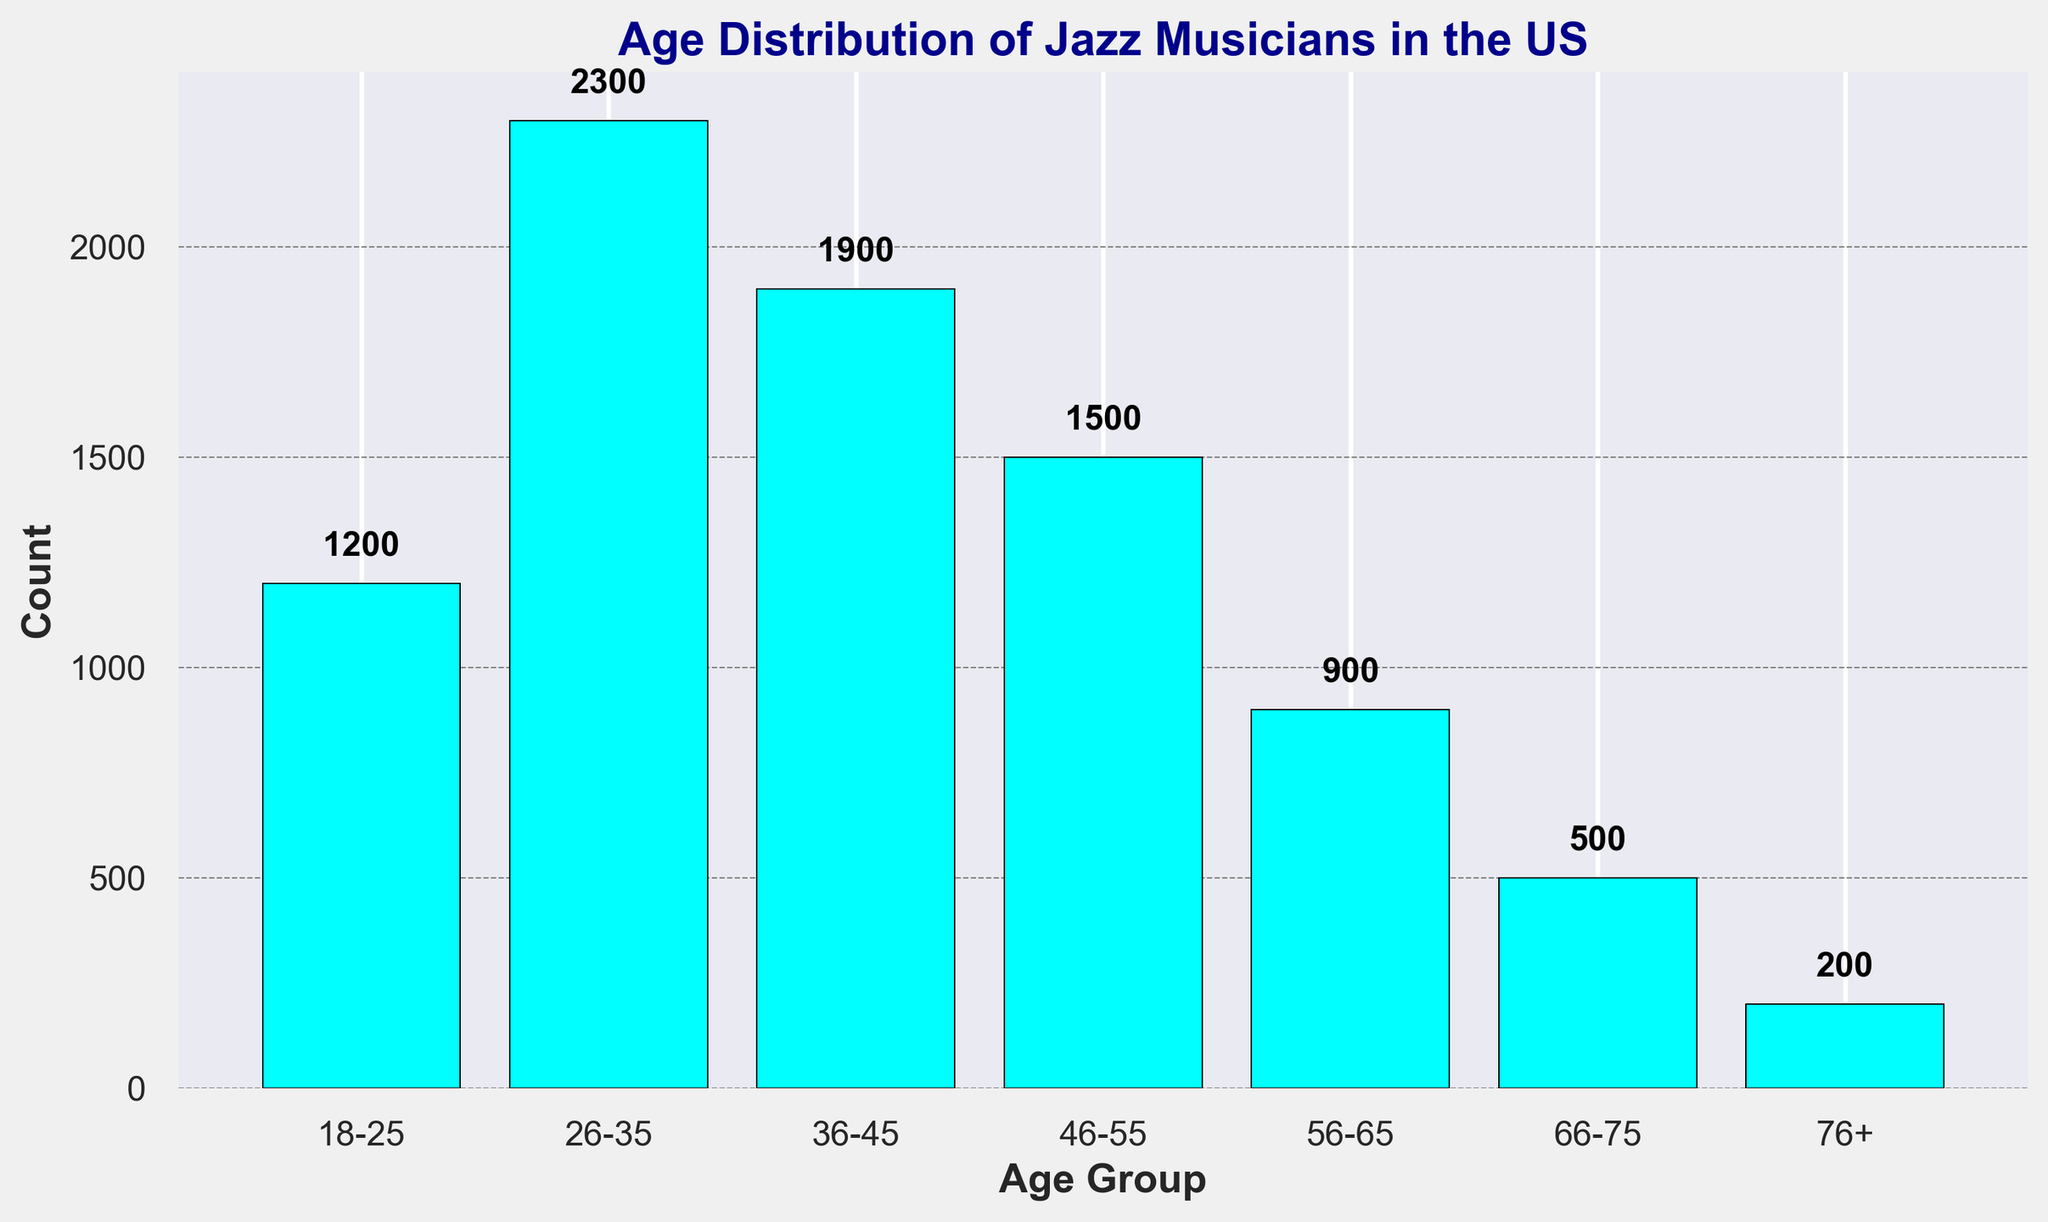What is the most common age group of jazz musicians in the US? The tallest bar in the chart represents the most common age group. The age group 26-35 has the tallest bar with a count of 2300.
Answer: 26-35 Which age group has the smallest number of jazz musicians? The shortest bar in the chart represents the age group with the smallest number. The age group 76+ has the shortest bar with a count of 200.
Answer: 76+ What is the combined count of jazz musicians under 36 years old? Sum the counts of the age groups 18-25 and 26-35: 1200 + 2300 = 3500.
Answer: 3500 How many more jazz musicians are there in the age group 36-45 compared to the age group 56-65? Find the difference between the counts of the two age groups: 1900 - 900 = 1000.
Answer: 1000 What is the total number of jazz musicians represented in the chart? Sum the counts of all the age groups: 1200 + 2300 + 1900 + 1500 + 900 + 500 + 200 = 8500.
Answer: 8500 How does the number of jazz musicians in the age group 46-55 compare to the number in the age group 26-35? Compare the counts: the age group 46-55 has 1500 musicians, while 26-35 has 2300. The comparison shows 46-55 has fewer musicians.
Answer: Fewer What is the median age group of jazz musicians in the US based on the counts? Arrange the groups by count and find the middle value: 200, 500, 900, 1200, 1500, 1900, 2300. The middle value is 1500 corresponding to the age group 46-55.
Answer: 46-55 What is the relative height of the bar representing the age group 56-65 compared to its neighbors (46-55 and 66-75)? The bar for the age group 56-65 is taller than the bar for 66-75 (900 vs. 500) and shorter than the bar for 46-55 (900 vs. 1500).
Answer: Taller than 66-75, shorter than 46-55 